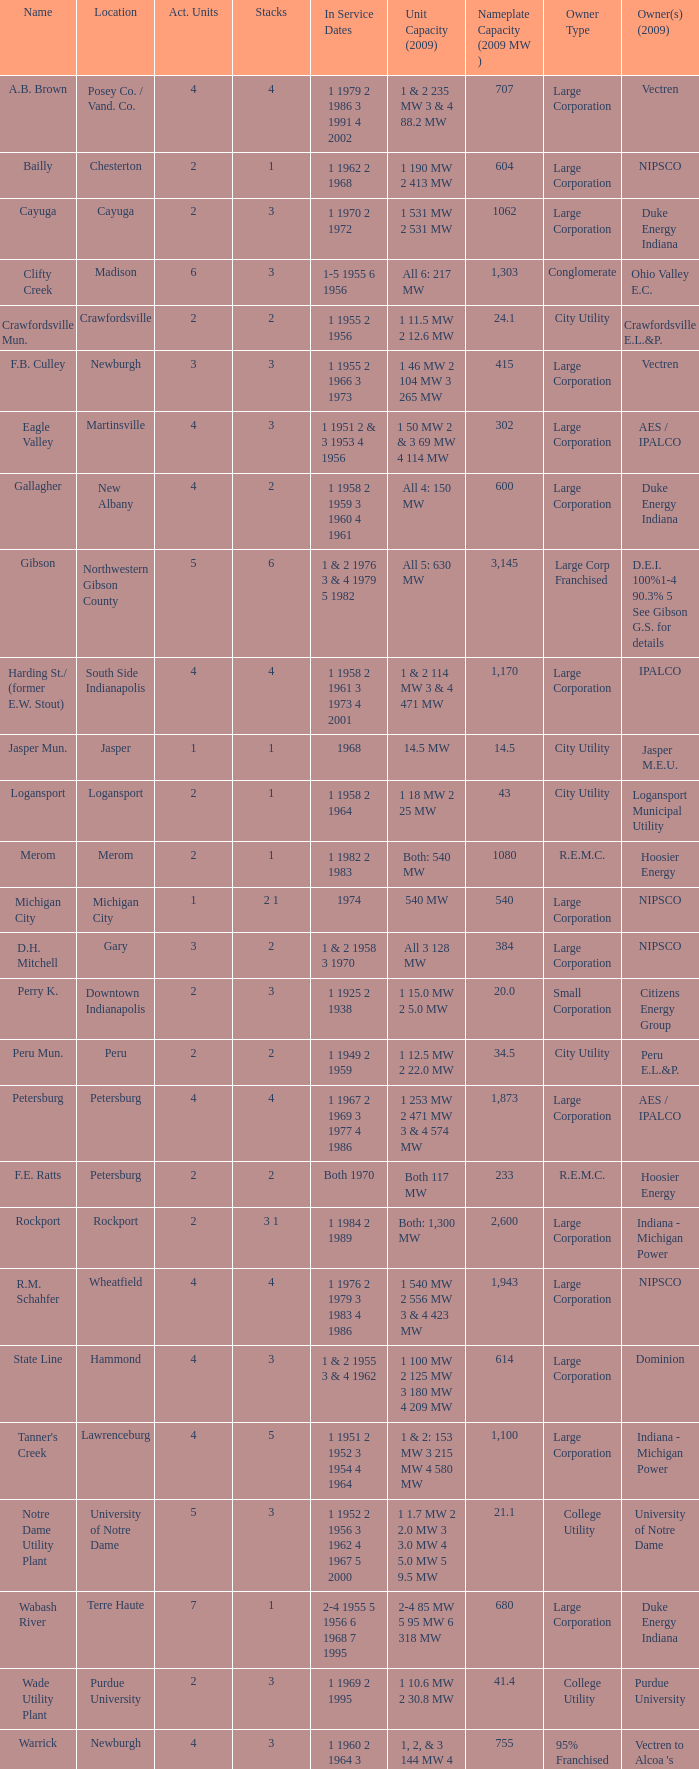Name the number for service dates for hoosier energy for petersburg 1.0. 